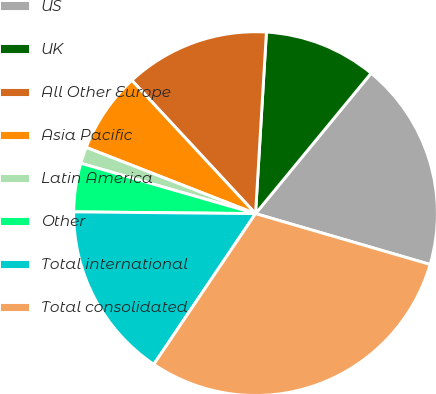<chart> <loc_0><loc_0><loc_500><loc_500><pie_chart><fcel>US<fcel>UK<fcel>All Other Europe<fcel>Asia Pacific<fcel>Latin America<fcel>Other<fcel>Total international<fcel>Total consolidated<nl><fcel>18.55%<fcel>10.01%<fcel>12.86%<fcel>7.16%<fcel>1.47%<fcel>4.31%<fcel>15.7%<fcel>29.94%<nl></chart> 